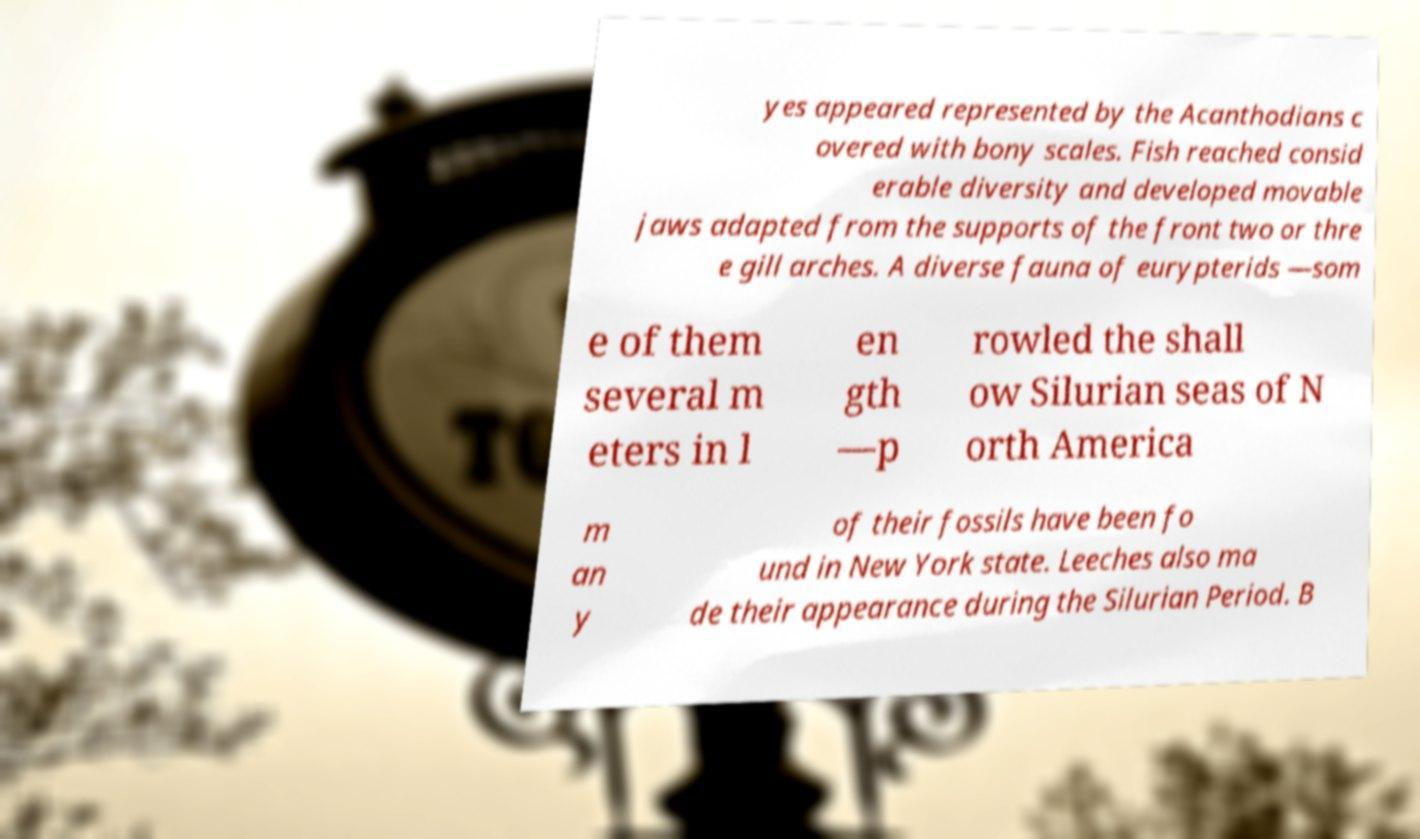Can you read and provide the text displayed in the image?This photo seems to have some interesting text. Can you extract and type it out for me? yes appeared represented by the Acanthodians c overed with bony scales. Fish reached consid erable diversity and developed movable jaws adapted from the supports of the front two or thre e gill arches. A diverse fauna of eurypterids —som e of them several m eters in l en gth —p rowled the shall ow Silurian seas of N orth America m an y of their fossils have been fo und in New York state. Leeches also ma de their appearance during the Silurian Period. B 